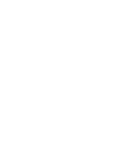Convert code to text. <code><loc_0><loc_0><loc_500><loc_500><_Dockerfile_>


</code> 